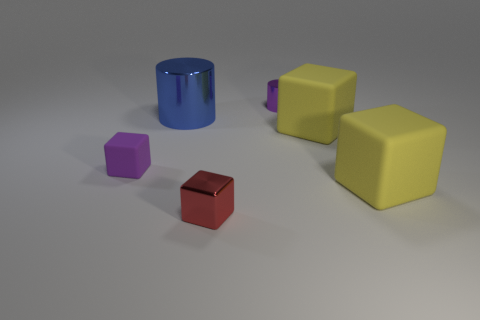There is a red cube; is its size the same as the purple object on the left side of the tiny red block?
Provide a succinct answer. Yes. There is a large rubber block that is behind the tiny rubber cube; what is its color?
Provide a succinct answer. Yellow. There is a metallic thing that is the same color as the small rubber cube; what is its shape?
Your answer should be very brief. Cylinder. What is the shape of the tiny object to the left of the tiny red shiny block?
Give a very brief answer. Cube. How many green things are either shiny objects or tiny matte objects?
Your answer should be very brief. 0. Do the small cylinder and the purple block have the same material?
Keep it short and to the point. No. What number of blue metallic things are right of the purple metallic object?
Offer a very short reply. 0. What is the large object that is behind the purple matte cube and to the right of the big cylinder made of?
Provide a short and direct response. Rubber. What number of balls are either purple shiny objects or yellow objects?
Your answer should be compact. 0. What material is the small purple thing that is the same shape as the red metallic object?
Provide a short and direct response. Rubber. 